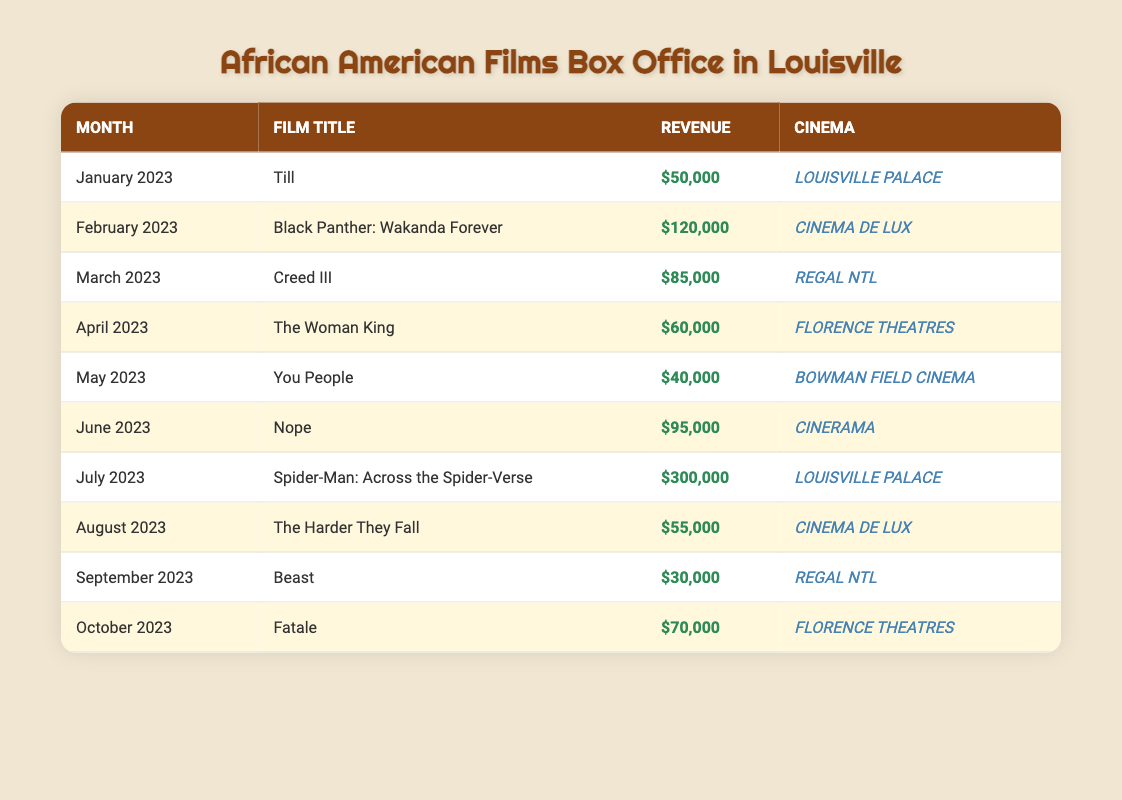What was the highest monthly box office revenue for an African American film? The highest revenue recorded in the table is $300,000 for the film "Spider-Man: Across the Spider-Verse" in July 2023.
Answer: $300,000 In what month did "The Woman King" screen, and what was its revenue? "The Woman King" premiered in April 2023 and generated revenue of $60,000.
Answer: April 2023, $60,000 How much more revenue did "Black Panther: Wakanda Forever" generate compared to "Creed III"? "Black Panther: Wakanda Forever" earned $120,000, while "Creed III" earned $85,000. The difference is $120,000 - $85,000 = $35,000.
Answer: $35,000 Was "Nope" screened at the same cinema as "Fatale"? "Nope" was shown at CINERAMA while "Fatale" was screened at FLORENCE THEATRES, indicating they were not at the same cinema.
Answer: No What is the total box office revenue for African American films from January to June 2023? To find the total revenue from January to June 2023, we add the revenues: $50,000 (Till) + $120,000 (Black Panther) + $85,000 (Creed III) + $60,000 (The Woman King) + $40,000 (You People) + $95,000 (Nope) = $450,000.
Answer: $450,000 Which film had the lowest revenue, and what was that amount? The film with the lowest revenue is "Beast," which generated $30,000 in September 2023.
Answer: $30,000 Did any film exceed $100,000 in revenue? Yes, "Black Panther: Wakanda Forever" with $120,000 and "Spider-Man: Across the Spider-Verse" with $300,000 both exceeded $100,000.
Answer: Yes What was the average revenue for African American films in August and September 2023? The revenue for August is $55,000 (The Harder They Fall) and for September is $30,000 (Beast). The average is ($55,000 + $30,000) / 2 = $42,500.
Answer: $42,500 What month had the least activity for African American films based on revenue? The month with the lowest revenue was September 2023 when "Beast" brought in $30,000, indicating it had the least box office activity.
Answer: September 2023 